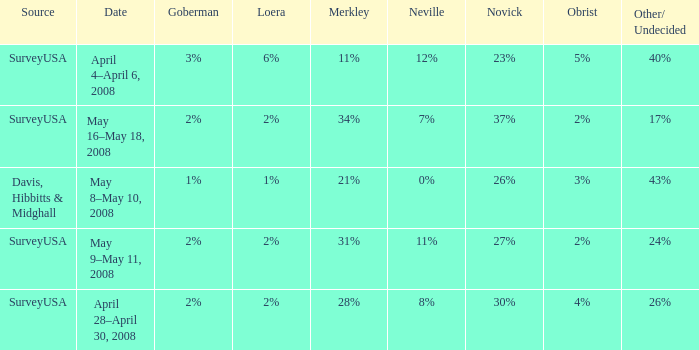Which Goberman has a Date of april 28–april 30, 2008? 2%. 